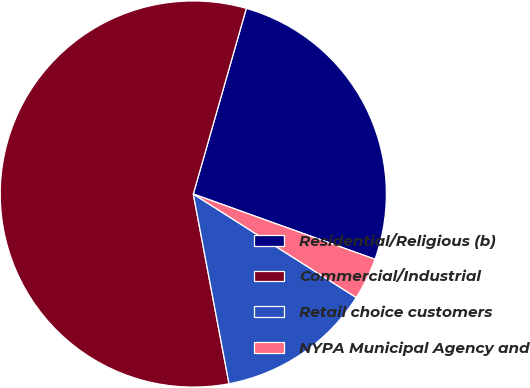Convert chart. <chart><loc_0><loc_0><loc_500><loc_500><pie_chart><fcel>Residential/Religious (b)<fcel>Commercial/Industrial<fcel>Retail choice customers<fcel>NYPA Municipal Agency and<nl><fcel>26.06%<fcel>57.39%<fcel>13.03%<fcel>3.52%<nl></chart> 